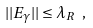Convert formula to latex. <formula><loc_0><loc_0><loc_500><loc_500>| | E _ { \gamma } | | \leq \lambda _ { R } \ ,</formula> 